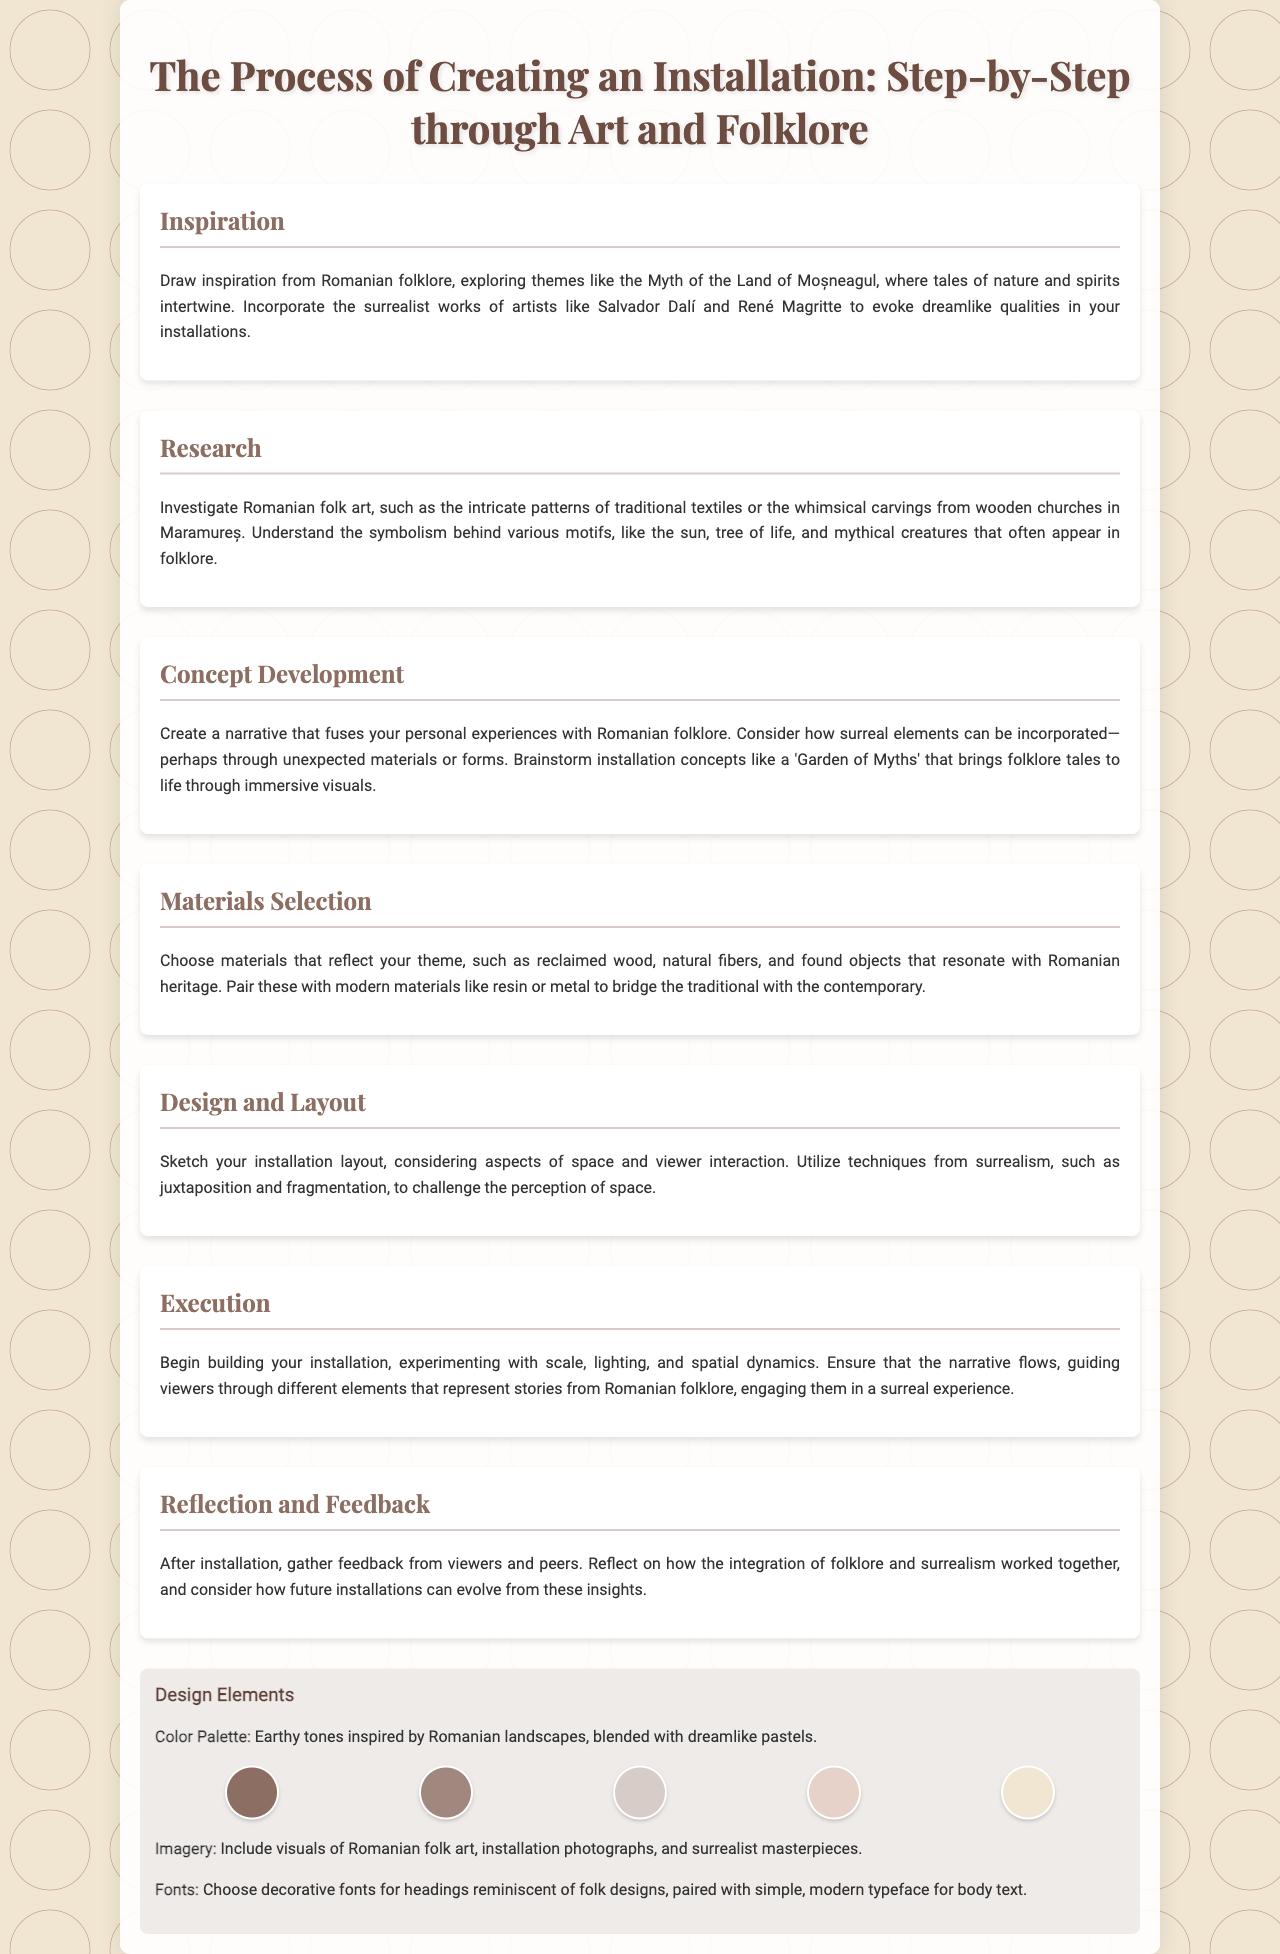What is the title of the brochure? The title of the brochure is stated prominently at the top of the document.
Answer: The Process of Creating an Installation: Step-by-Step through Art and Folklore How many sections are in the brochure? The brochure contains sections detailing various aspects of the installation process.
Answer: Seven Which artist's works are mentioned as influences in the inspiration section? The inspiration section lists key artists whose works influence the installation artist.
Answer: Salvador Dalí What materials are suggested for selection in the materials section? The materials section advises on the types of materials that resonate with the theme.
Answer: Reclaimed wood, natural fibers, and found objects What narrative concept is proposed in the concept development section? The concept development section suggests creating a narrative that blends personal experience with folklore.
Answer: Garden of Myths What is emphasized in the reflection and feedback section? The reflection and feedback section highlights the importance of gathering insights post-installation.
Answer: Integration of folklore and surrealism 